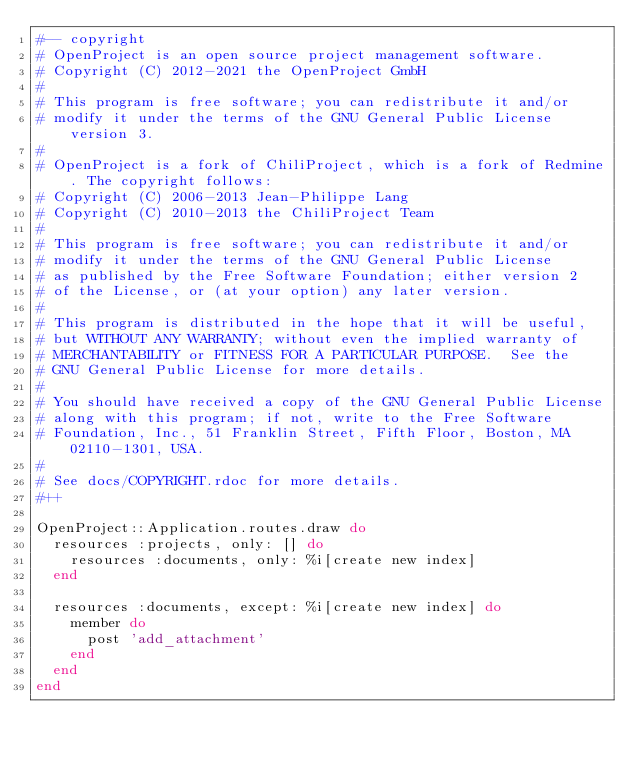<code> <loc_0><loc_0><loc_500><loc_500><_Ruby_>#-- copyright
# OpenProject is an open source project management software.
# Copyright (C) 2012-2021 the OpenProject GmbH
#
# This program is free software; you can redistribute it and/or
# modify it under the terms of the GNU General Public License version 3.
#
# OpenProject is a fork of ChiliProject, which is a fork of Redmine. The copyright follows:
# Copyright (C) 2006-2013 Jean-Philippe Lang
# Copyright (C) 2010-2013 the ChiliProject Team
#
# This program is free software; you can redistribute it and/or
# modify it under the terms of the GNU General Public License
# as published by the Free Software Foundation; either version 2
# of the License, or (at your option) any later version.
#
# This program is distributed in the hope that it will be useful,
# but WITHOUT ANY WARRANTY; without even the implied warranty of
# MERCHANTABILITY or FITNESS FOR A PARTICULAR PURPOSE.  See the
# GNU General Public License for more details.
#
# You should have received a copy of the GNU General Public License
# along with this program; if not, write to the Free Software
# Foundation, Inc., 51 Franklin Street, Fifth Floor, Boston, MA  02110-1301, USA.
#
# See docs/COPYRIGHT.rdoc for more details.
#++

OpenProject::Application.routes.draw do
  resources :projects, only: [] do
    resources :documents, only: %i[create new index]
  end

  resources :documents, except: %i[create new index] do
    member do
      post 'add_attachment'
    end
  end
end
</code> 